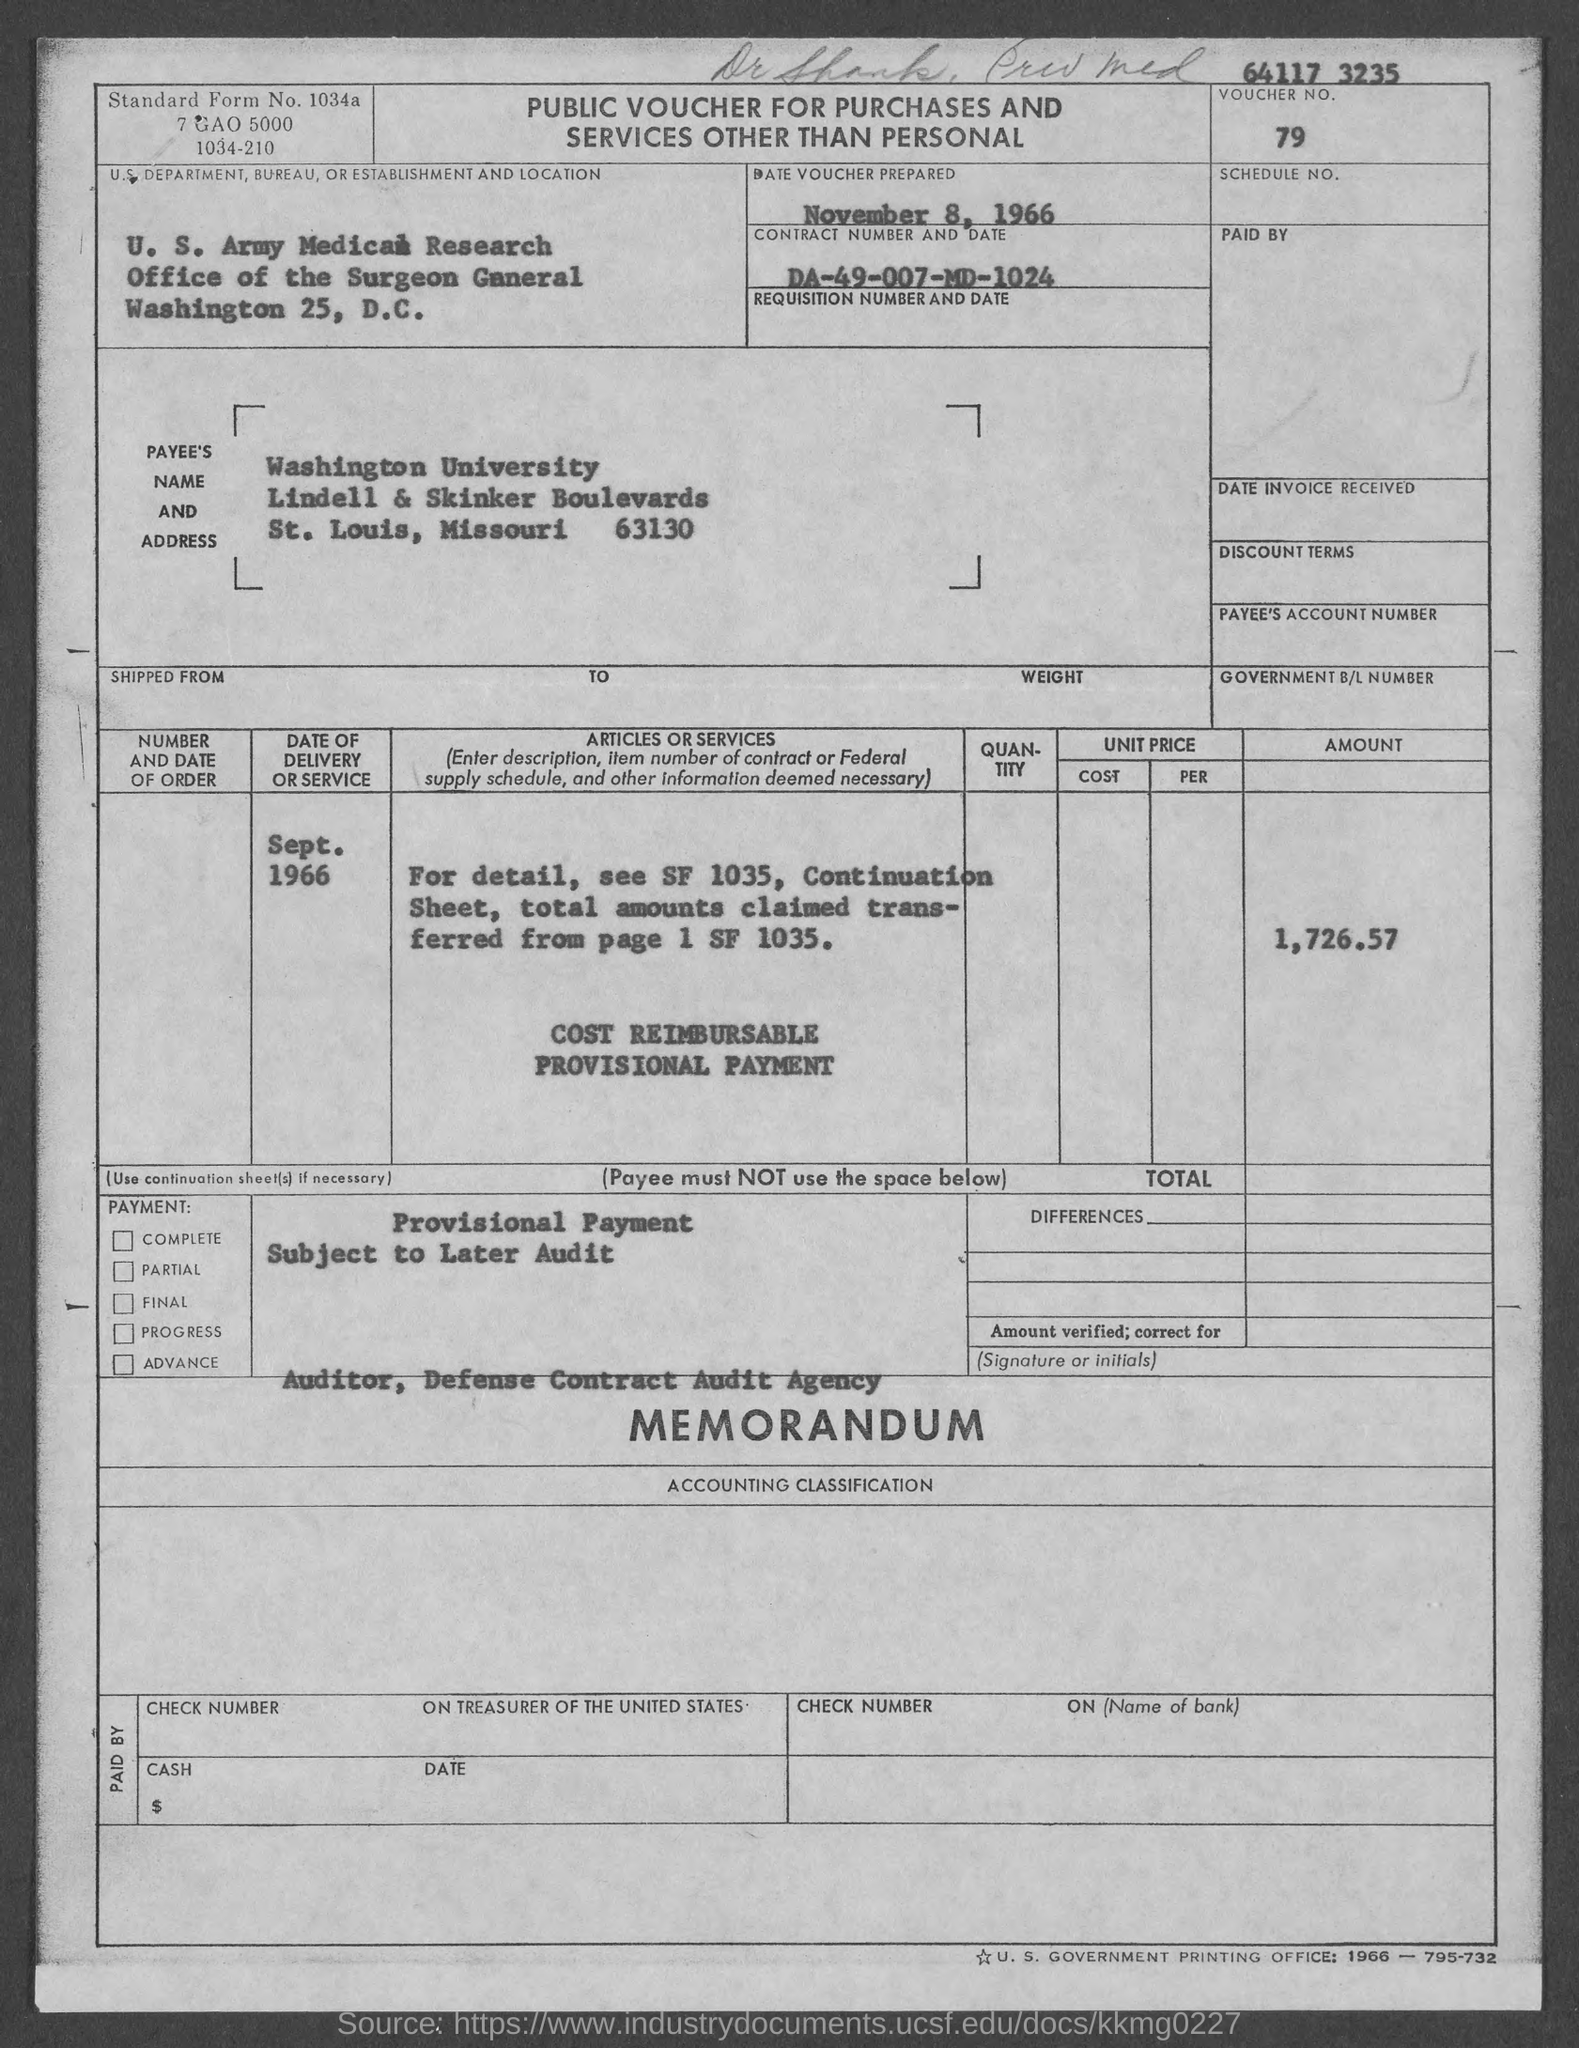Highlight a few significant elements in this photo. The date of the voucher prepared is November 8, 1966. The date of delivery of the service mentioned in the voucher is September 1966. The voucher number as mentioned in the document is 79... The standard form number indicated in the voucher is 1034a... The contract number and date given in the voucher are DA-49-007-MD-1024. 